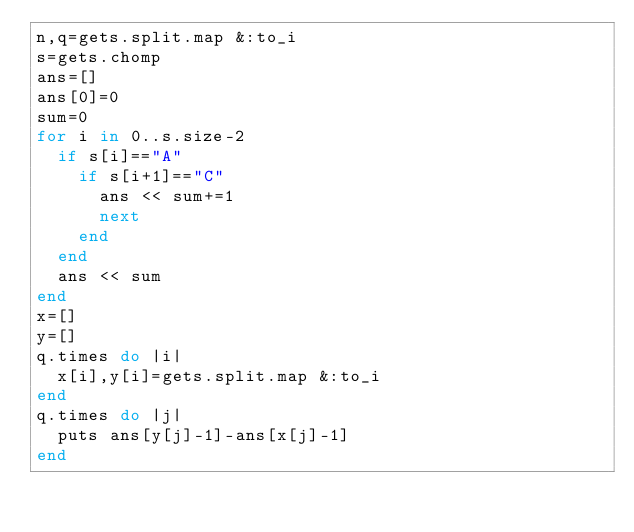<code> <loc_0><loc_0><loc_500><loc_500><_Ruby_>n,q=gets.split.map &:to_i
s=gets.chomp
ans=[]
ans[0]=0
sum=0
for i in 0..s.size-2
  if s[i]=="A"
    if s[i+1]=="C"
      ans << sum+=1
      next
    end
  end
  ans << sum
end
x=[]
y=[]
q.times do |i|
  x[i],y[i]=gets.split.map &:to_i
end
q.times do |j|
  puts ans[y[j]-1]-ans[x[j]-1]
end
</code> 